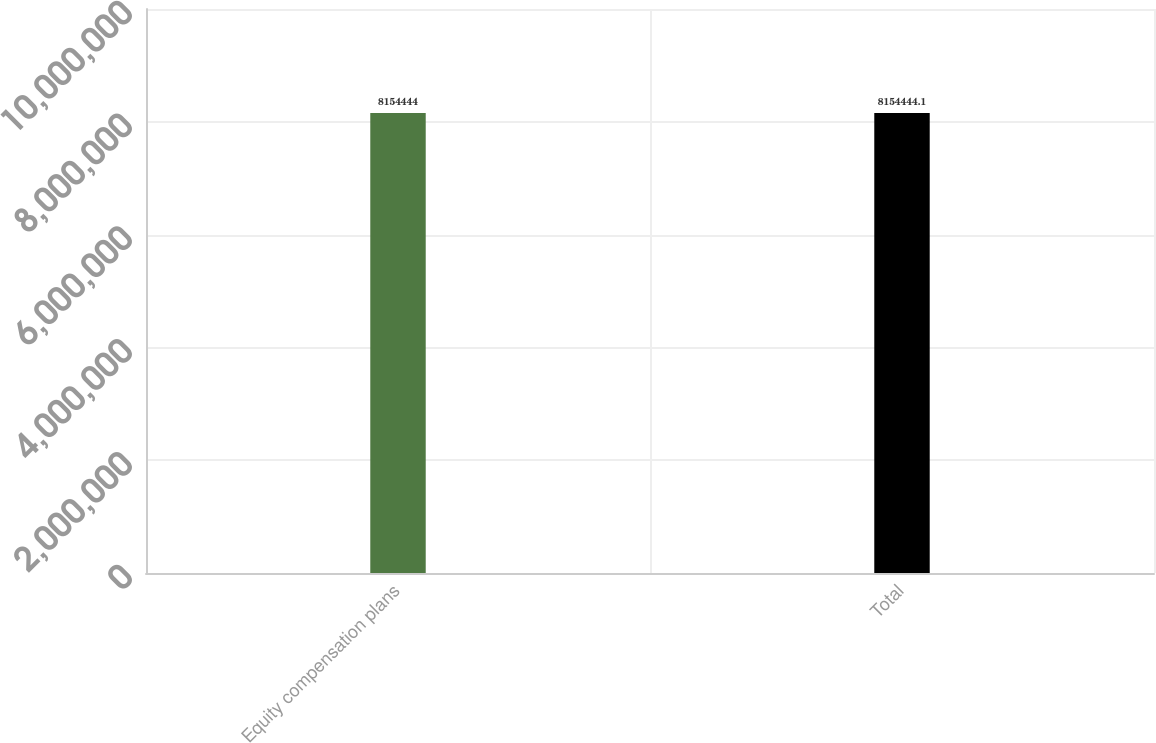<chart> <loc_0><loc_0><loc_500><loc_500><bar_chart><fcel>Equity compensation plans<fcel>Total<nl><fcel>8.15444e+06<fcel>8.15444e+06<nl></chart> 